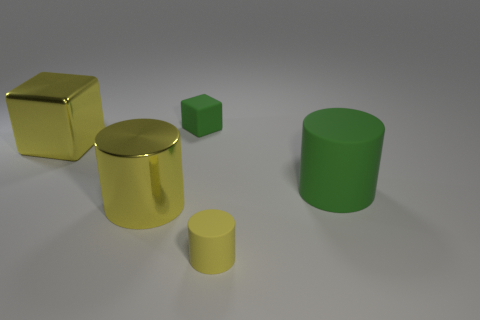Subtract all metallic cylinders. How many cylinders are left? 2 Add 4 small red metal cylinders. How many objects exist? 9 Subtract all brown balls. How many yellow cylinders are left? 2 Subtract all green cubes. How many cubes are left? 1 Subtract all cubes. How many objects are left? 3 Add 1 big red metallic objects. How many big red metallic objects exist? 1 Subtract 0 gray blocks. How many objects are left? 5 Subtract 2 cylinders. How many cylinders are left? 1 Subtract all yellow cubes. Subtract all yellow cylinders. How many cubes are left? 1 Subtract all tiny green rubber cylinders. Subtract all cylinders. How many objects are left? 2 